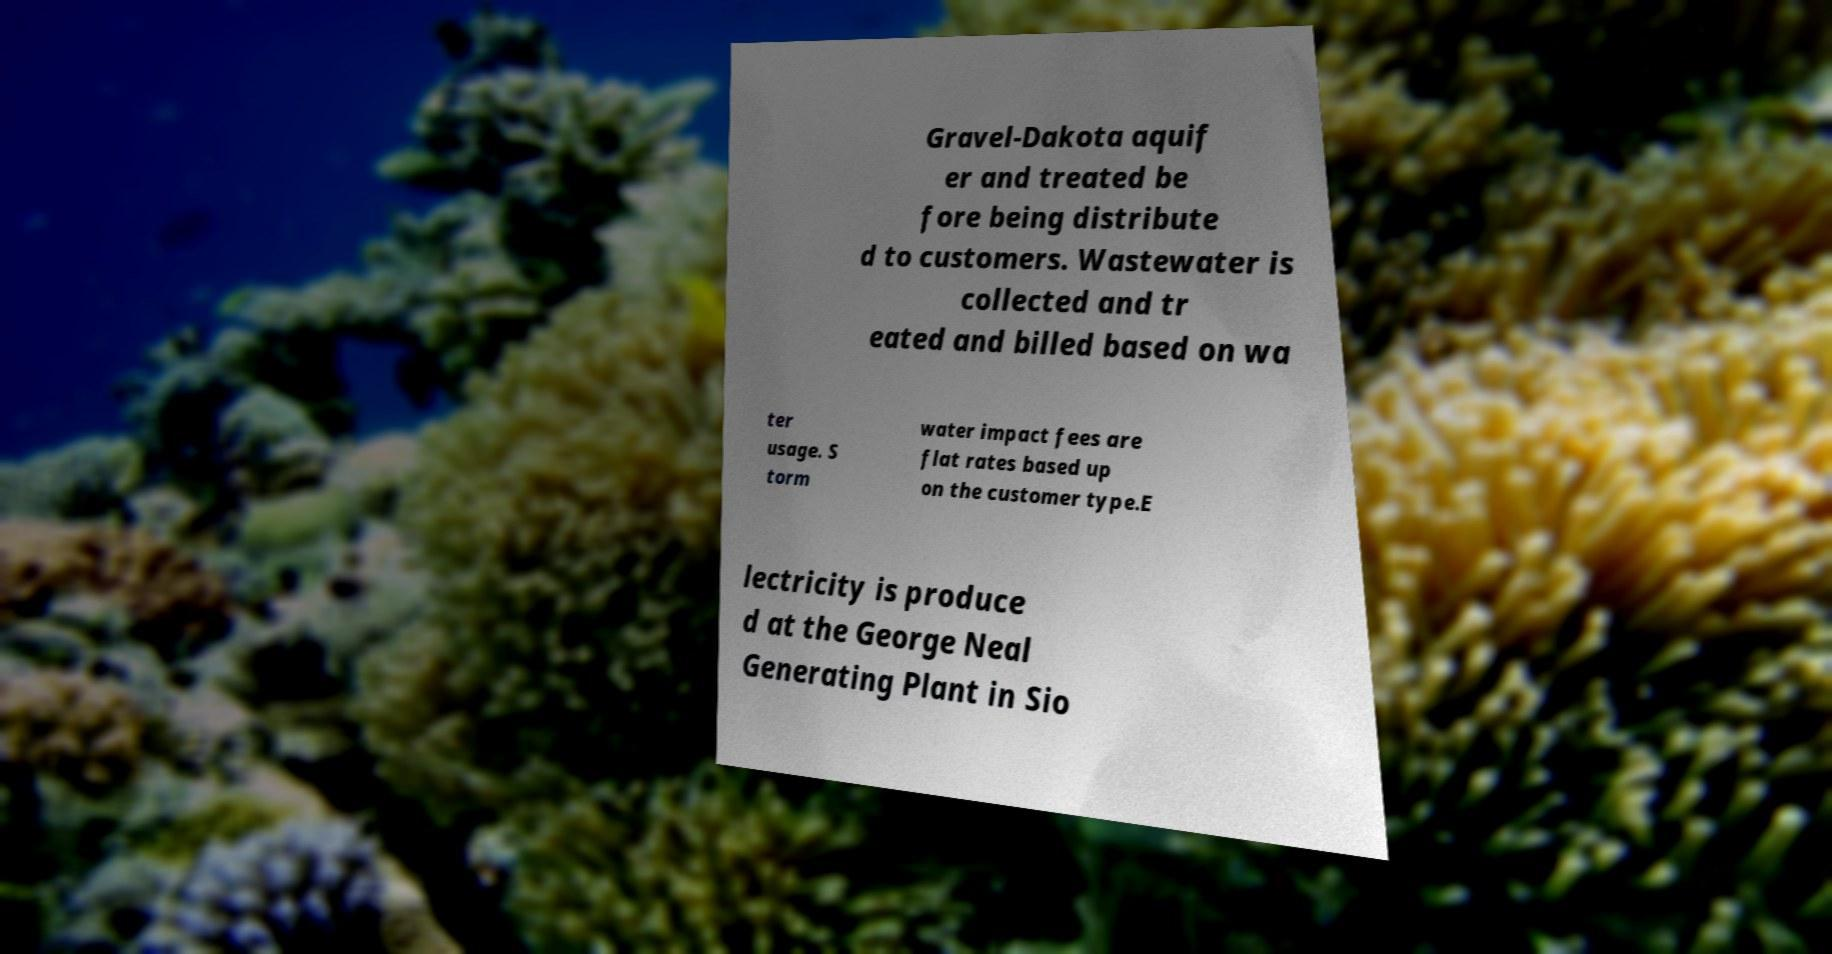What messages or text are displayed in this image? I need them in a readable, typed format. Gravel-Dakota aquif er and treated be fore being distribute d to customers. Wastewater is collected and tr eated and billed based on wa ter usage. S torm water impact fees are flat rates based up on the customer type.E lectricity is produce d at the George Neal Generating Plant in Sio 